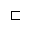Convert formula to latex. <formula><loc_0><loc_0><loc_500><loc_500>\sqsubset</formula> 